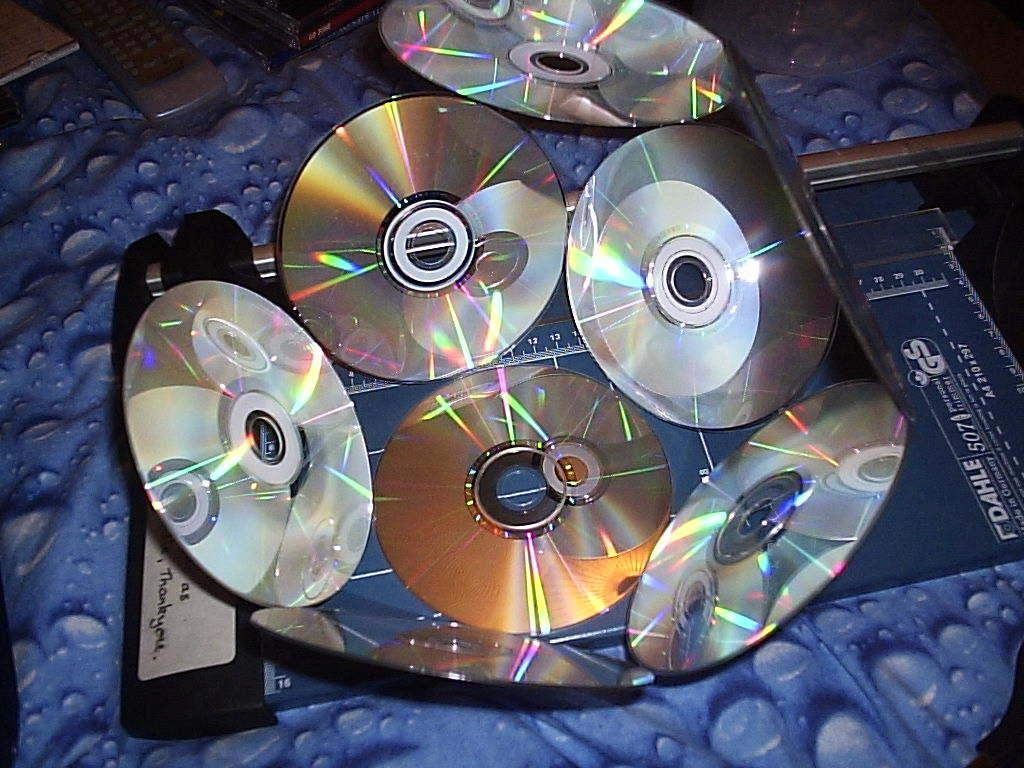What is the main subject of the image? The main subject of the image is a bowl of CDs arranged in a unique formation. What is located beside the bowl of CDs? There is a remote beside the bowl of CDs. How many feet are visible in the image? There are no feet visible in the image. What type of memory is stored on the CDs in the image? The image does not provide information about the content or type of memory stored on the CDs. 